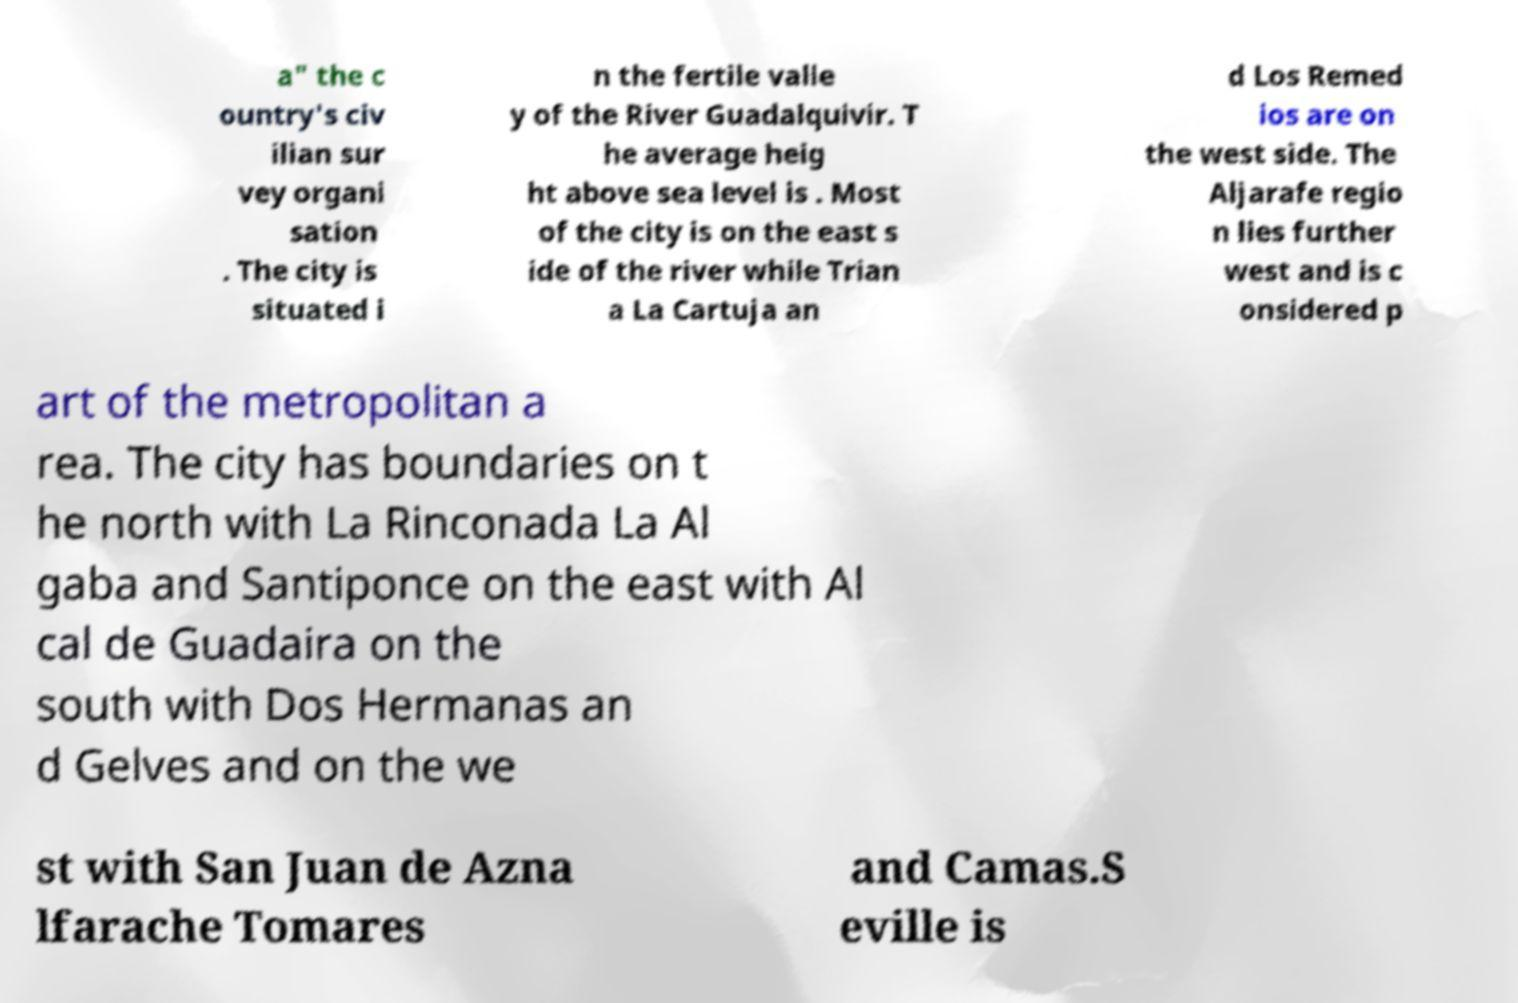I need the written content from this picture converted into text. Can you do that? a" the c ountry's civ ilian sur vey organi sation . The city is situated i n the fertile valle y of the River Guadalquivir. T he average heig ht above sea level is . Most of the city is on the east s ide of the river while Trian a La Cartuja an d Los Remed ios are on the west side. The Aljarafe regio n lies further west and is c onsidered p art of the metropolitan a rea. The city has boundaries on t he north with La Rinconada La Al gaba and Santiponce on the east with Al cal de Guadaira on the south with Dos Hermanas an d Gelves and on the we st with San Juan de Azna lfarache Tomares and Camas.S eville is 